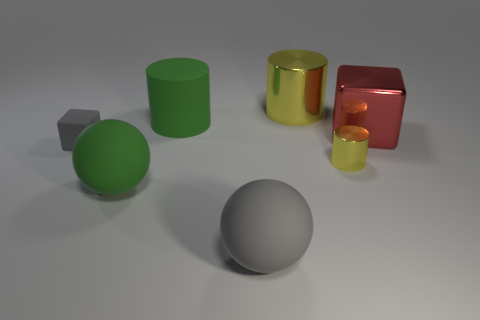There is a large green object to the right of the green ball; what material is it?
Offer a very short reply. Rubber. Are there any other things that are made of the same material as the tiny yellow cylinder?
Your answer should be very brief. Yes. Is the number of big green matte things that are on the left side of the large metal cube greater than the number of small rubber cubes?
Make the answer very short. Yes. Is there a green rubber thing on the right side of the rubber sphere that is to the right of the big green thing that is in front of the tiny yellow object?
Your answer should be compact. No. There is a big metal cube; are there any big red blocks on the right side of it?
Offer a terse response. No. How many large spheres are the same color as the large block?
Offer a terse response. 0. What is the size of the cube that is made of the same material as the large green ball?
Offer a terse response. Small. There is a gray thing that is on the left side of the green matte object left of the green object behind the red metal block; what is its size?
Provide a short and direct response. Small. There is a yellow cylinder behind the small matte block; what size is it?
Your answer should be compact. Large. What number of red objects are either small matte blocks or metal cubes?
Provide a short and direct response. 1. 